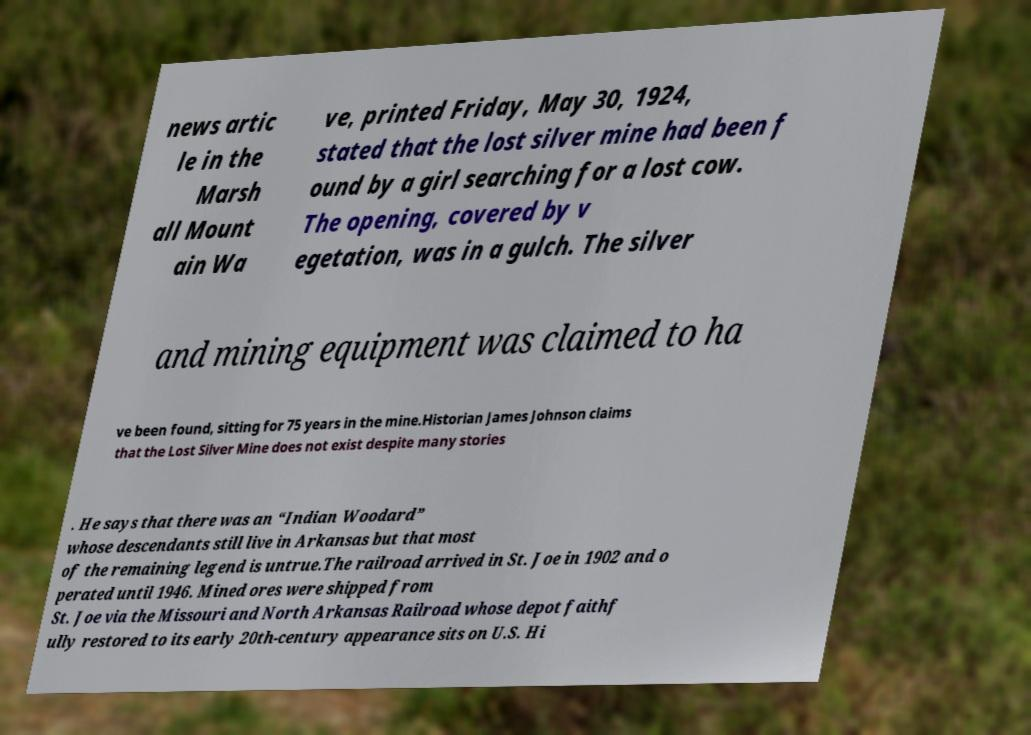Can you read and provide the text displayed in the image?This photo seems to have some interesting text. Can you extract and type it out for me? news artic le in the Marsh all Mount ain Wa ve, printed Friday, May 30, 1924, stated that the lost silver mine had been f ound by a girl searching for a lost cow. The opening, covered by v egetation, was in a gulch. The silver and mining equipment was claimed to ha ve been found, sitting for 75 years in the mine.Historian James Johnson claims that the Lost Silver Mine does not exist despite many stories . He says that there was an “Indian Woodard” whose descendants still live in Arkansas but that most of the remaining legend is untrue.The railroad arrived in St. Joe in 1902 and o perated until 1946. Mined ores were shipped from St. Joe via the Missouri and North Arkansas Railroad whose depot faithf ully restored to its early 20th-century appearance sits on U.S. Hi 